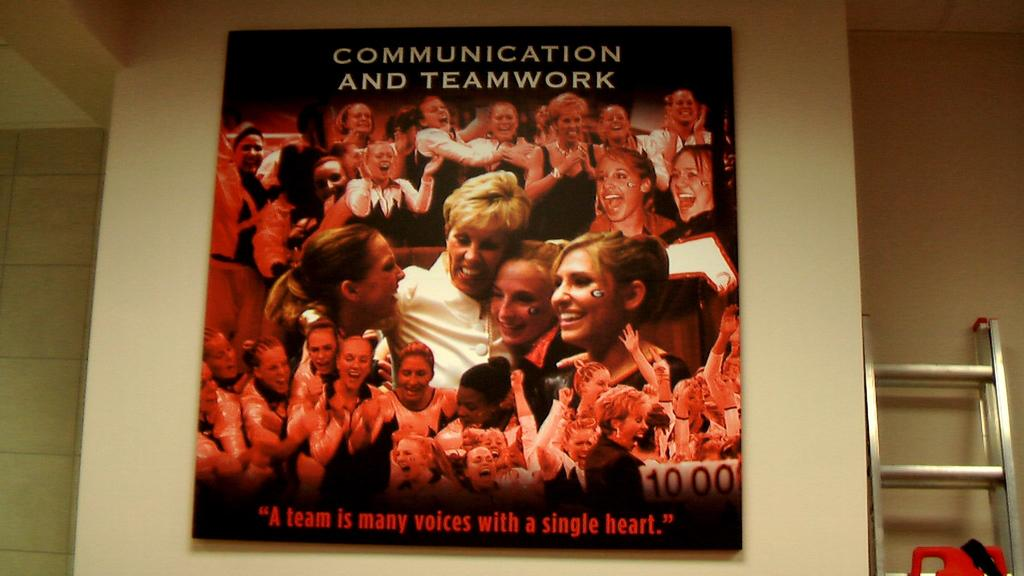<image>
Relay a brief, clear account of the picture shown. The poster features the catchphrase "A team is many voices with a single heart". 